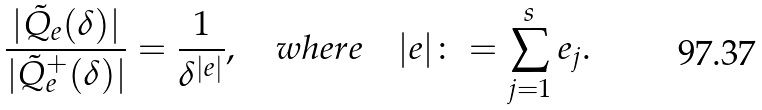Convert formula to latex. <formula><loc_0><loc_0><loc_500><loc_500>\frac { | \tilde { Q } _ { e } ( \delta ) | } { | \tilde { Q } _ { e } ^ { + } ( \delta ) | } = \frac { 1 } { \delta ^ { | e | } } , \quad w h e r e \quad | e | \colon = \sum _ { j = 1 } ^ { s } e _ { j } .</formula> 